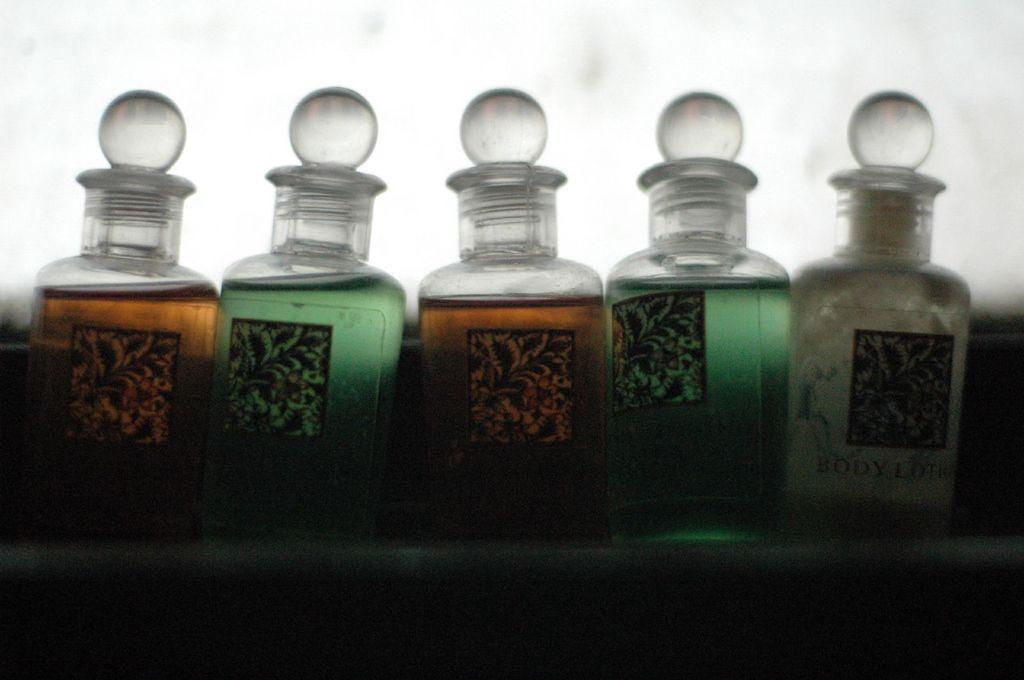<image>
Describe the image concisely. Five bottled items sit in a row, the right one of which is body lotion. 